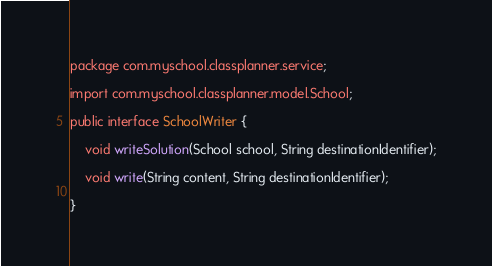<code> <loc_0><loc_0><loc_500><loc_500><_Java_>package com.myschool.classplanner.service;

import com.myschool.classplanner.model.School;

public interface SchoolWriter {

    void writeSolution(School school, String destinationIdentifier);

    void write(String content, String destinationIdentifier);

}
</code> 